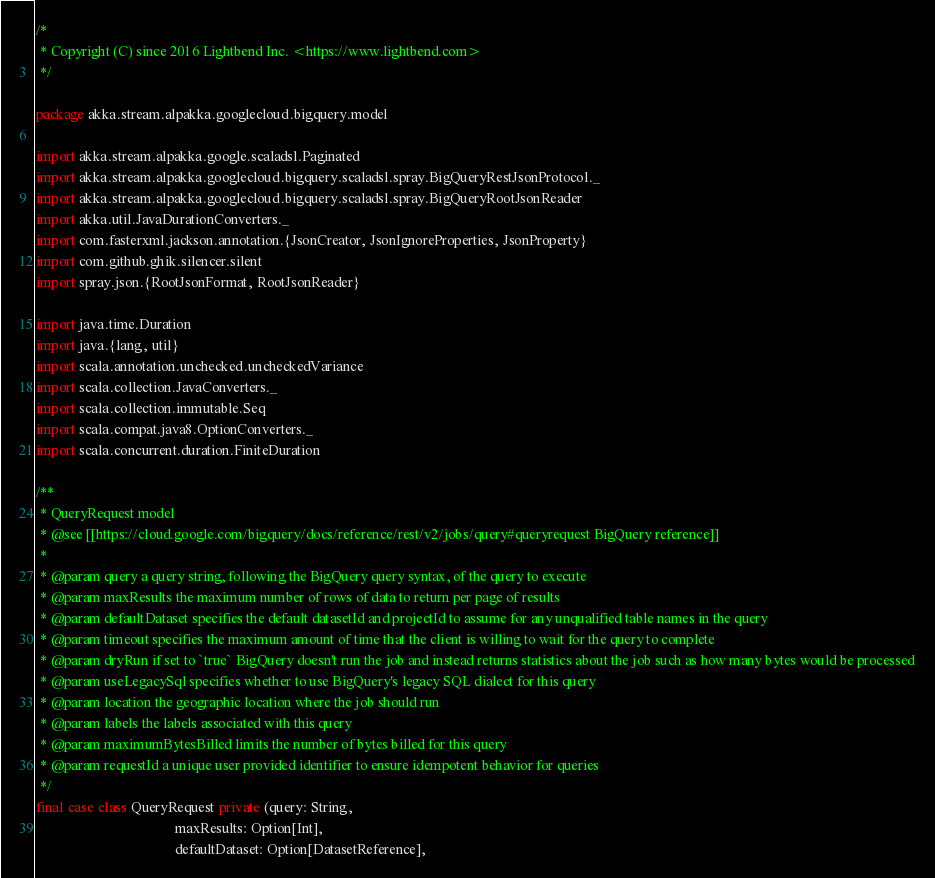Convert code to text. <code><loc_0><loc_0><loc_500><loc_500><_Scala_>/*
 * Copyright (C) since 2016 Lightbend Inc. <https://www.lightbend.com>
 */

package akka.stream.alpakka.googlecloud.bigquery.model

import akka.stream.alpakka.google.scaladsl.Paginated
import akka.stream.alpakka.googlecloud.bigquery.scaladsl.spray.BigQueryRestJsonProtocol._
import akka.stream.alpakka.googlecloud.bigquery.scaladsl.spray.BigQueryRootJsonReader
import akka.util.JavaDurationConverters._
import com.fasterxml.jackson.annotation.{JsonCreator, JsonIgnoreProperties, JsonProperty}
import com.github.ghik.silencer.silent
import spray.json.{RootJsonFormat, RootJsonReader}

import java.time.Duration
import java.{lang, util}
import scala.annotation.unchecked.uncheckedVariance
import scala.collection.JavaConverters._
import scala.collection.immutable.Seq
import scala.compat.java8.OptionConverters._
import scala.concurrent.duration.FiniteDuration

/**
 * QueryRequest model
 * @see [[https://cloud.google.com/bigquery/docs/reference/rest/v2/jobs/query#queryrequest BigQuery reference]]
 *
 * @param query a query string, following the BigQuery query syntax, of the query to execute
 * @param maxResults the maximum number of rows of data to return per page of results
 * @param defaultDataset specifies the default datasetId and projectId to assume for any unqualified table names in the query
 * @param timeout specifies the maximum amount of time that the client is willing to wait for the query to complete
 * @param dryRun if set to `true` BigQuery doesn't run the job and instead returns statistics about the job such as how many bytes would be processed
 * @param useLegacySql specifies whether to use BigQuery's legacy SQL dialect for this query
 * @param location the geographic location where the job should run
 * @param labels the labels associated with this query
 * @param maximumBytesBilled limits the number of bytes billed for this query
 * @param requestId a unique user provided identifier to ensure idempotent behavior for queries
 */
final case class QueryRequest private (query: String,
                                       maxResults: Option[Int],
                                       defaultDataset: Option[DatasetReference],</code> 